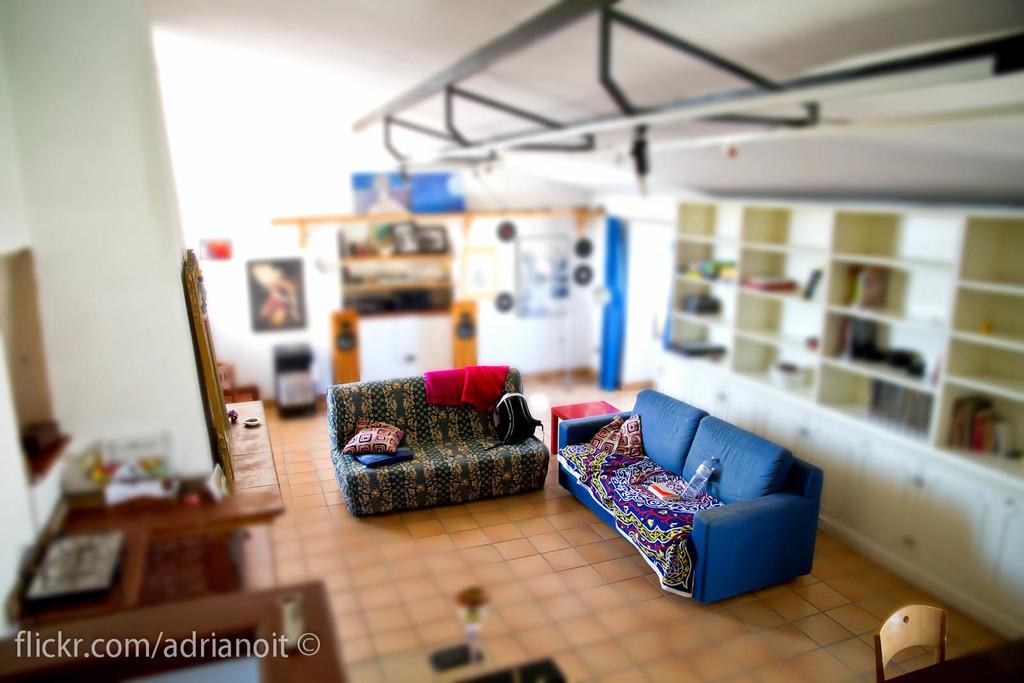<image>
Describe the image concisely. s stylized view of a living room with sofas in focus with words Flickr.com/adrianoit 